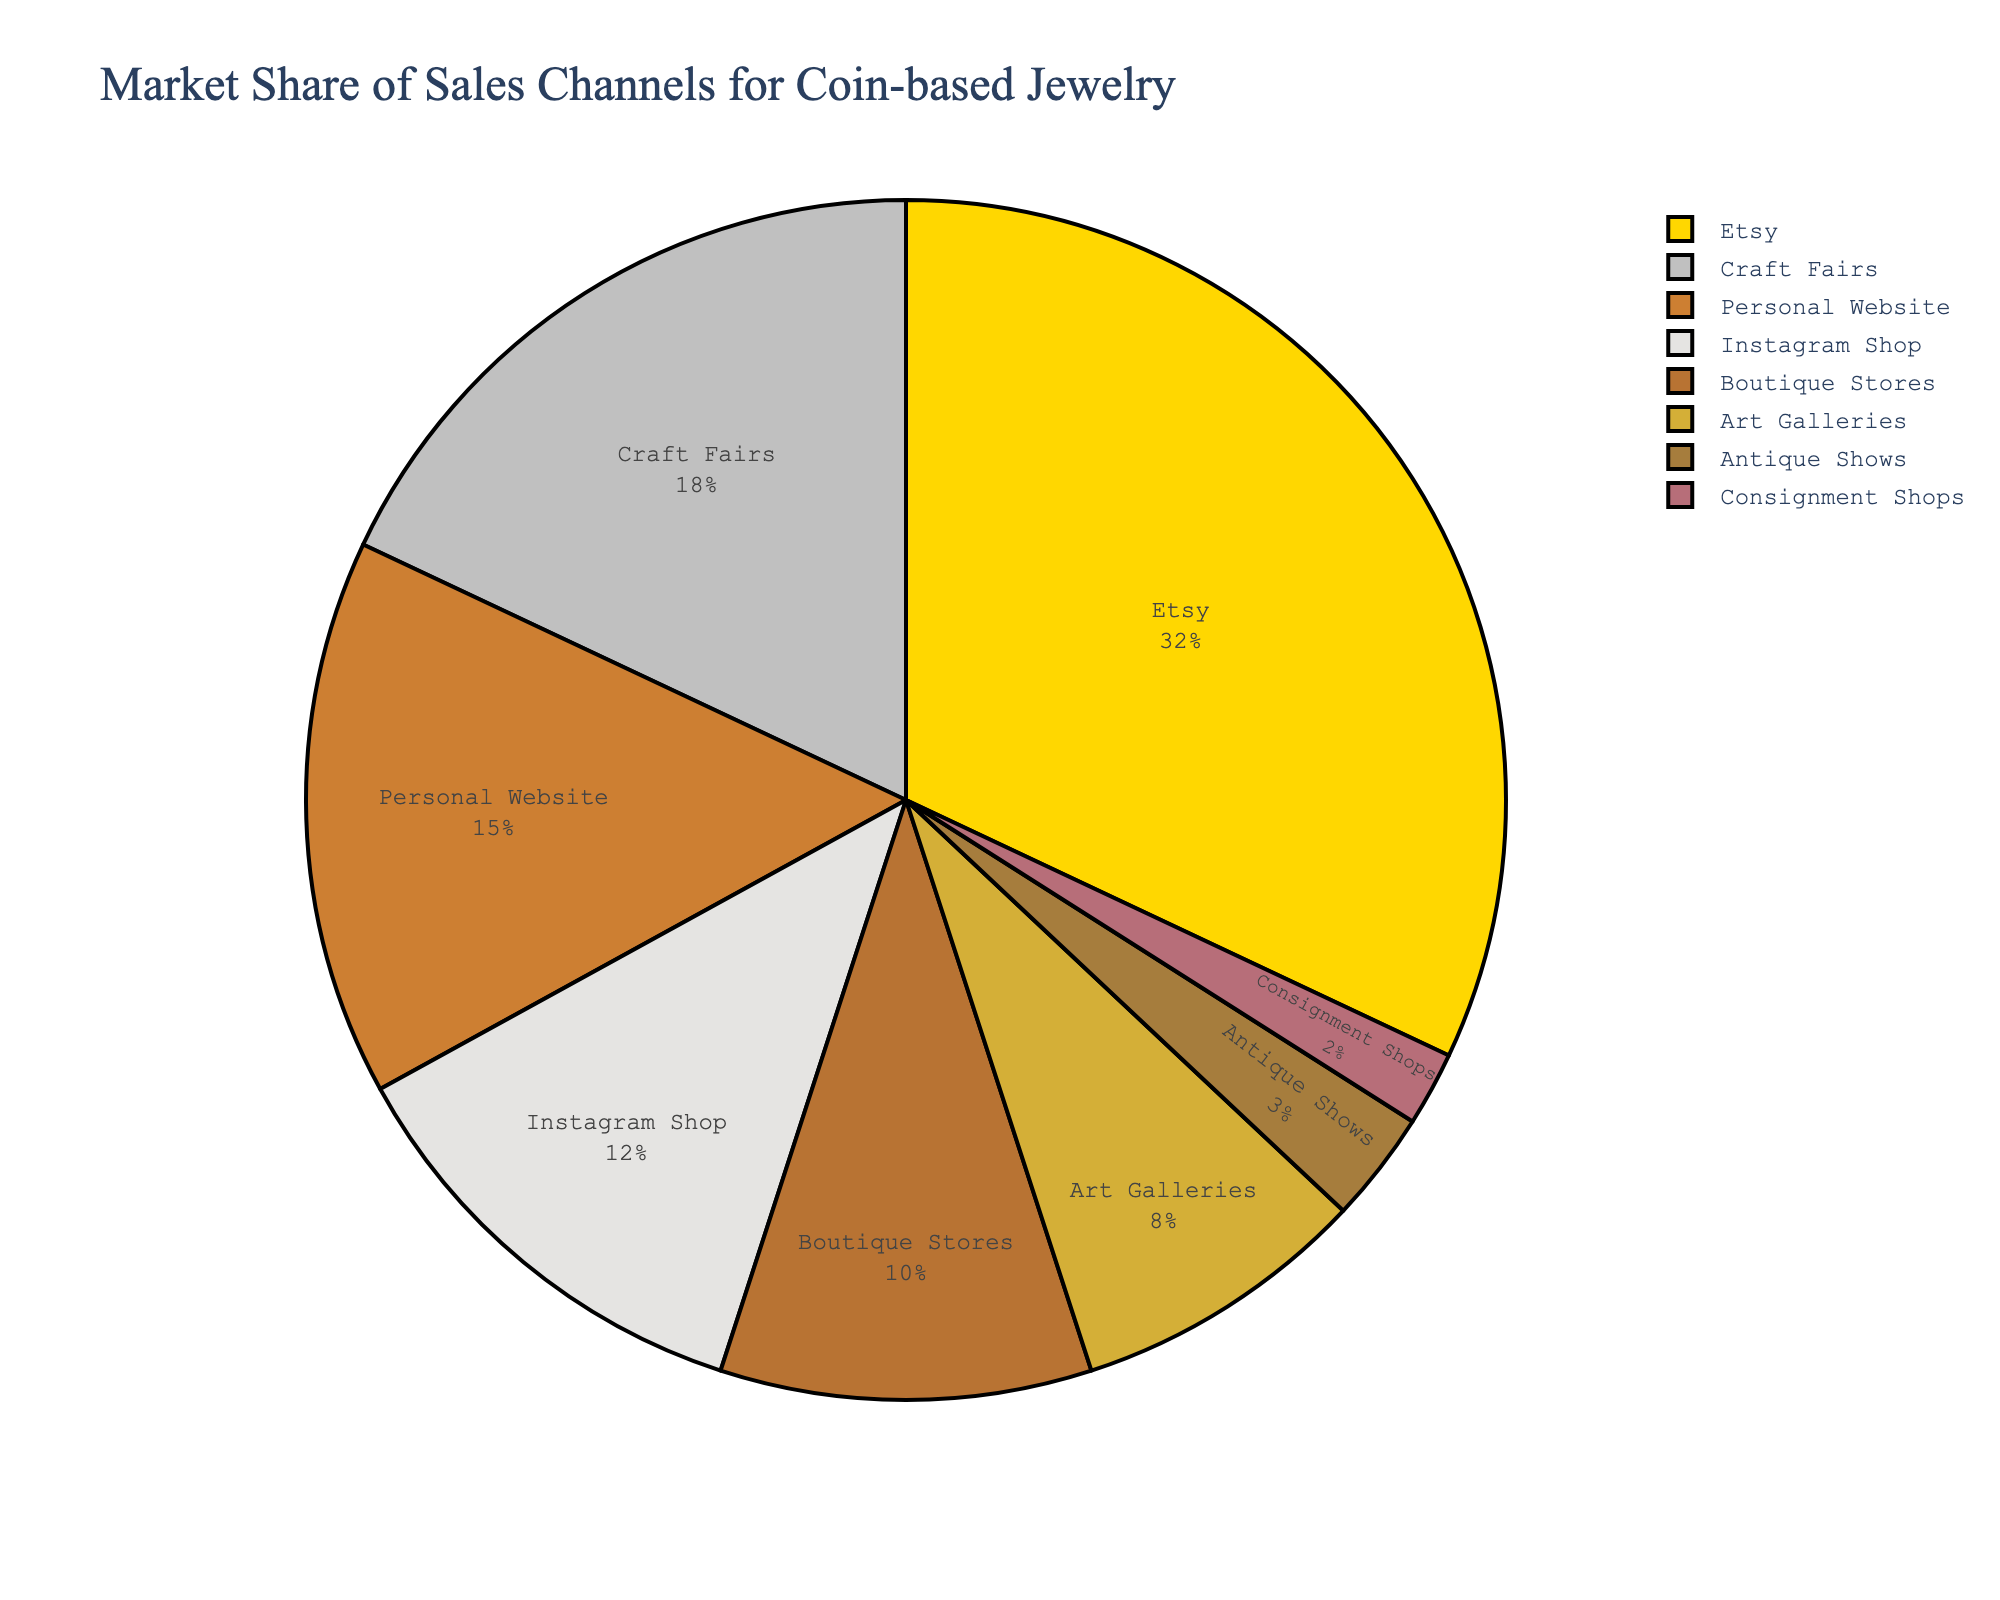Which sales channel has the largest market share? Look at the pie chart and identify the segment with the largest size. The label on this segment indicates which sales channel it represents.
Answer: Etsy What is the combined market share of Craft Fairs and Boutique Stores? Identify the segments corresponding to Craft Fairs and Boutique Stores and add their market share percentages together. Craft Fairs has 18% and Boutique Stores have 10%, so the total is 18% + 10% = 28%.
Answer: 28% How much larger is the market share of Etsy compared to Instagram Shop? Find the market share values for Etsy (32%) and Instagram Shop (12%). Subtract the smaller percentage from the larger one: 32% - 12% = 20%.
Answer: 20% Which sales channels have a market share less than 10%? Look for segments labeled with percentages less than 10%. This includes Art Galleries (8%), Antique Shows (3%), and Consignment Shops (2%).
Answer: Art Galleries, Antique Shows, Consignment Shops What is the average market share of the top three sales channels? Identify the top three segments: Etsy (32%), Craft Fairs (18%), and Personal Website (15%). Add their market shares and divide by 3: (32% + 18% + 15%) / 3 = 65% / 3 ≈ 21.67%
Answer: 21.67% Which sales channel has the smallest market share and what is it? Look for the smallest segment in the pie chart. The segment labeled Consignment Shops has the smallest market share of 2%.
Answer: Consignment Shops, 2% What is the difference in market share between the second and fourth largest sales channels? Identify the second largest (Craft Fairs, 18%) and the fourth largest (Instagram Shop, 12%) segments. Subtract the percentages: 18% - 12% = 6%.
Answer: 6% How many sales channels have a market share greater than 10%? Identify and count the segments with labels showing percentages greater than 10%. These are Etsy (32%), Craft Fairs (18%), Personal Website (15%), Instagram Shop (12%), and Boutique Stores (10%), which makes 5 segments.
Answer: 5 What is the total market share of Antique Shows and Consignment Shops combined? Find the market shares of Antique Shows (3%) and Consignment Shops (2%), then add them together: 3% + 2% = 5%.
Answer: 5% 